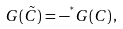<formula> <loc_0><loc_0><loc_500><loc_500>G ( \tilde { C } ) = - ^ { ^ { * } } G ( C ) \, ,</formula> 